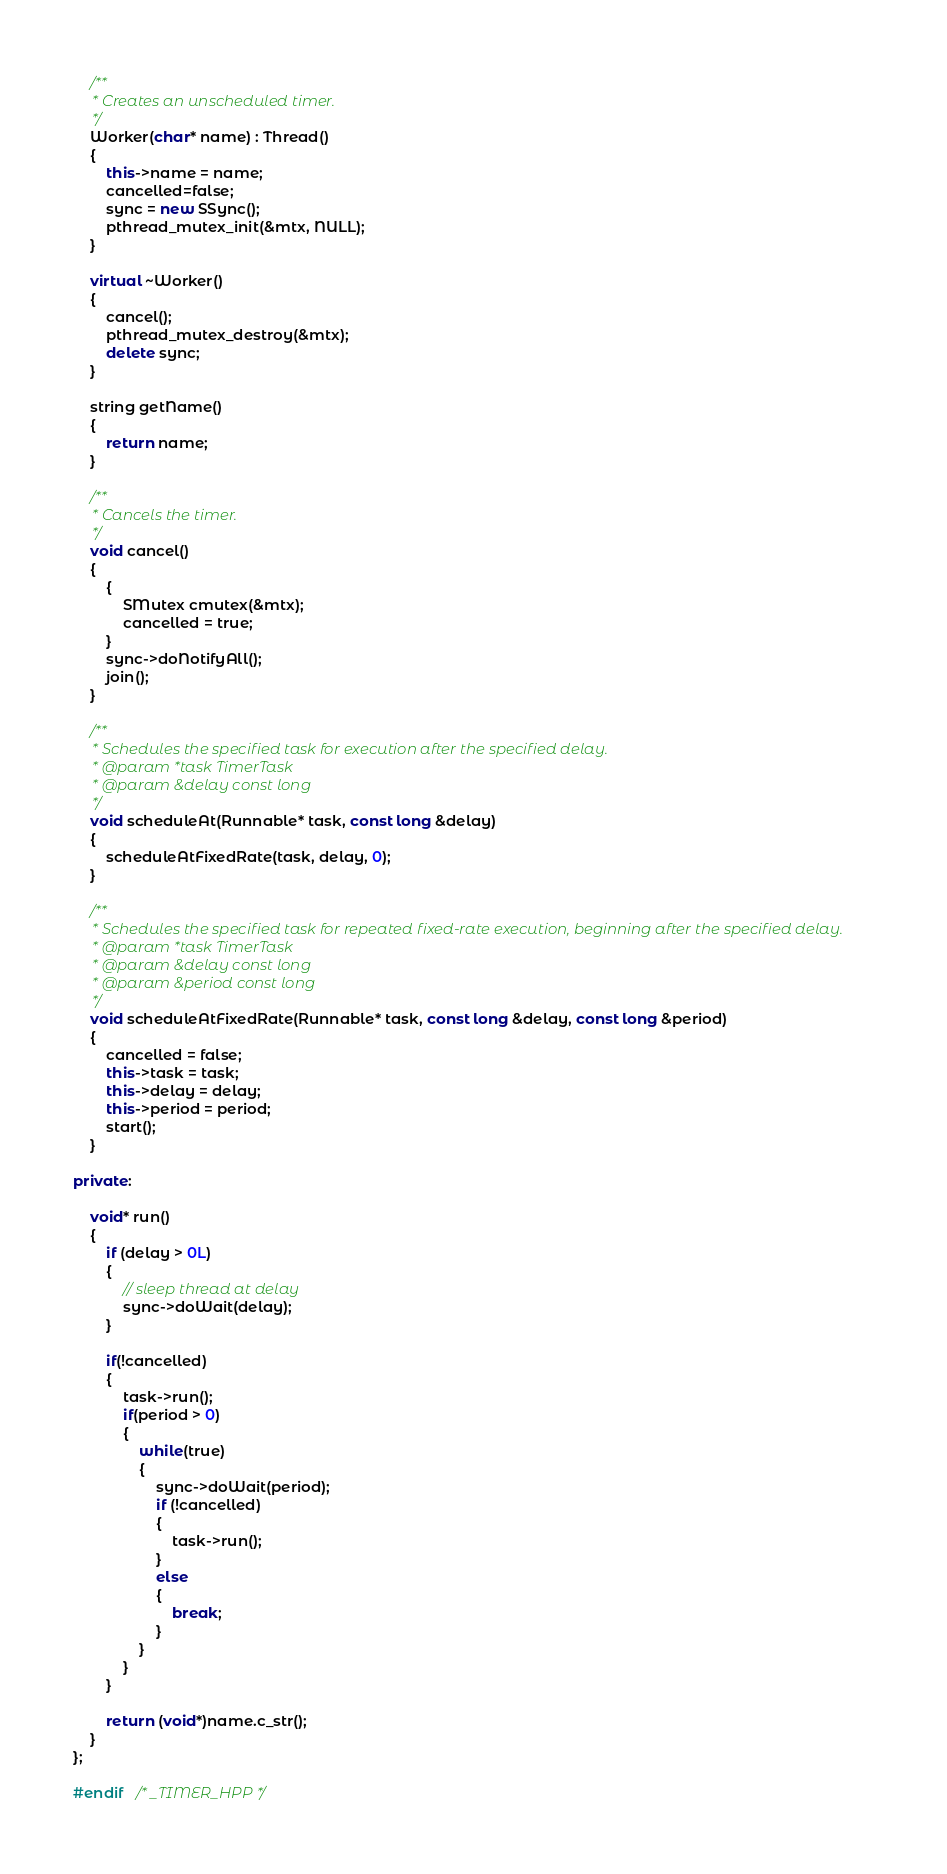<code> <loc_0><loc_0><loc_500><loc_500><_C++_>    /**
     * Creates an unscheduled timer.
     */
    Worker(char* name) : Thread()
    {
        this->name = name;
        cancelled=false;
        sync = new SSync();
        pthread_mutex_init(&mtx, NULL);
    }

    virtual ~Worker()
    {
        cancel();
        pthread_mutex_destroy(&mtx);
        delete sync;
    }

    string getName()
    {
        return name;
    }
    
    /**
     * Cancels the timer.
     */
    void cancel()
    {
        {
            SMutex cmutex(&mtx);
            cancelled = true;
        }
        sync->doNotifyAll();
        join();
    }

    /**
     * Schedules the specified task for execution after the specified delay.
     * @param *task TimerTask
     * @param &delay const long
     */
    void scheduleAt(Runnable* task, const long &delay)
    {
        scheduleAtFixedRate(task, delay, 0);
    }

    /**
     * Schedules the specified task for repeated fixed-rate execution, beginning after the specified delay.
     * @param *task TimerTask
     * @param &delay const long
     * @param &period const long
     */
    void scheduleAtFixedRate(Runnable* task, const long &delay, const long &period)
    {
        cancelled = false;
        this->task = task;
        this->delay = delay;
        this->period = period;
        start();
    }

private:

    void* run()
    {
        if (delay > 0L)
        {
            // sleep thread at delay
            sync->doWait(delay);
        }
        
        if(!cancelled)
        {
            task->run();
            if(period > 0)
            {
                while(true)
                {
                    sync->doWait(period);
                    if (!cancelled)
                    {
                        task->run();
                    }
                    else
                    {
                        break;
                    }
                }
            }
        }
        
        return (void*)name.c_str();
    }
};

#endif	/* _TIMER_HPP */
</code> 